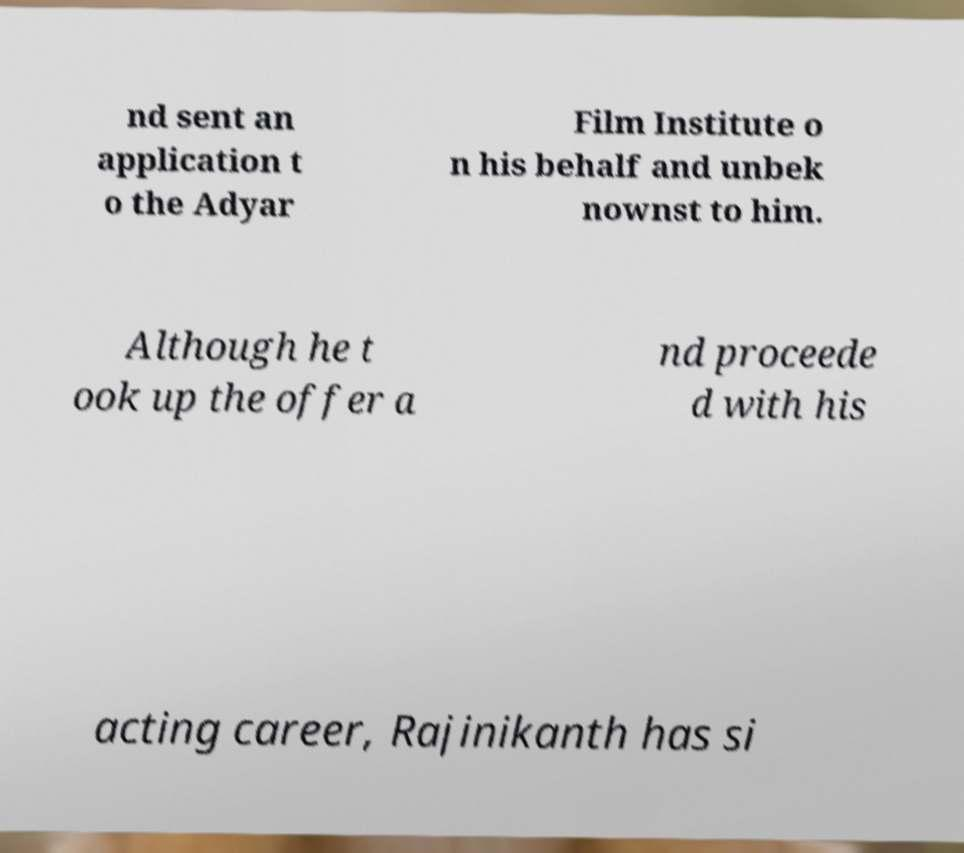I need the written content from this picture converted into text. Can you do that? nd sent an application t o the Adyar Film Institute o n his behalf and unbek nownst to him. Although he t ook up the offer a nd proceede d with his acting career, Rajinikanth has si 